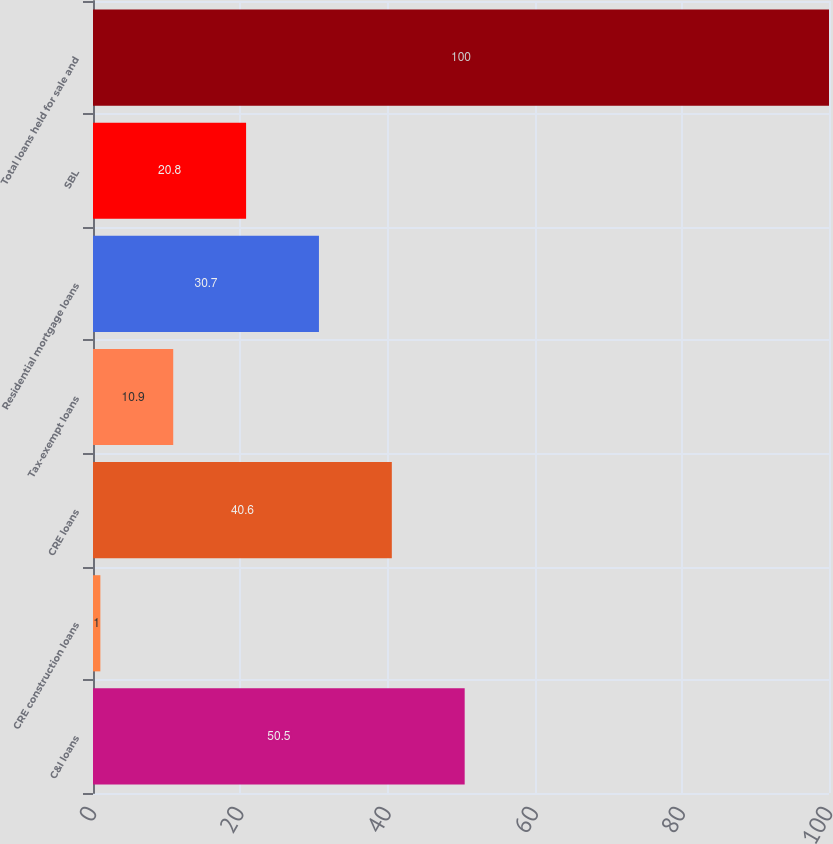Convert chart to OTSL. <chart><loc_0><loc_0><loc_500><loc_500><bar_chart><fcel>C&I loans<fcel>CRE construction loans<fcel>CRE loans<fcel>Tax-exempt loans<fcel>Residential mortgage loans<fcel>SBL<fcel>Total loans held for sale and<nl><fcel>50.5<fcel>1<fcel>40.6<fcel>10.9<fcel>30.7<fcel>20.8<fcel>100<nl></chart> 